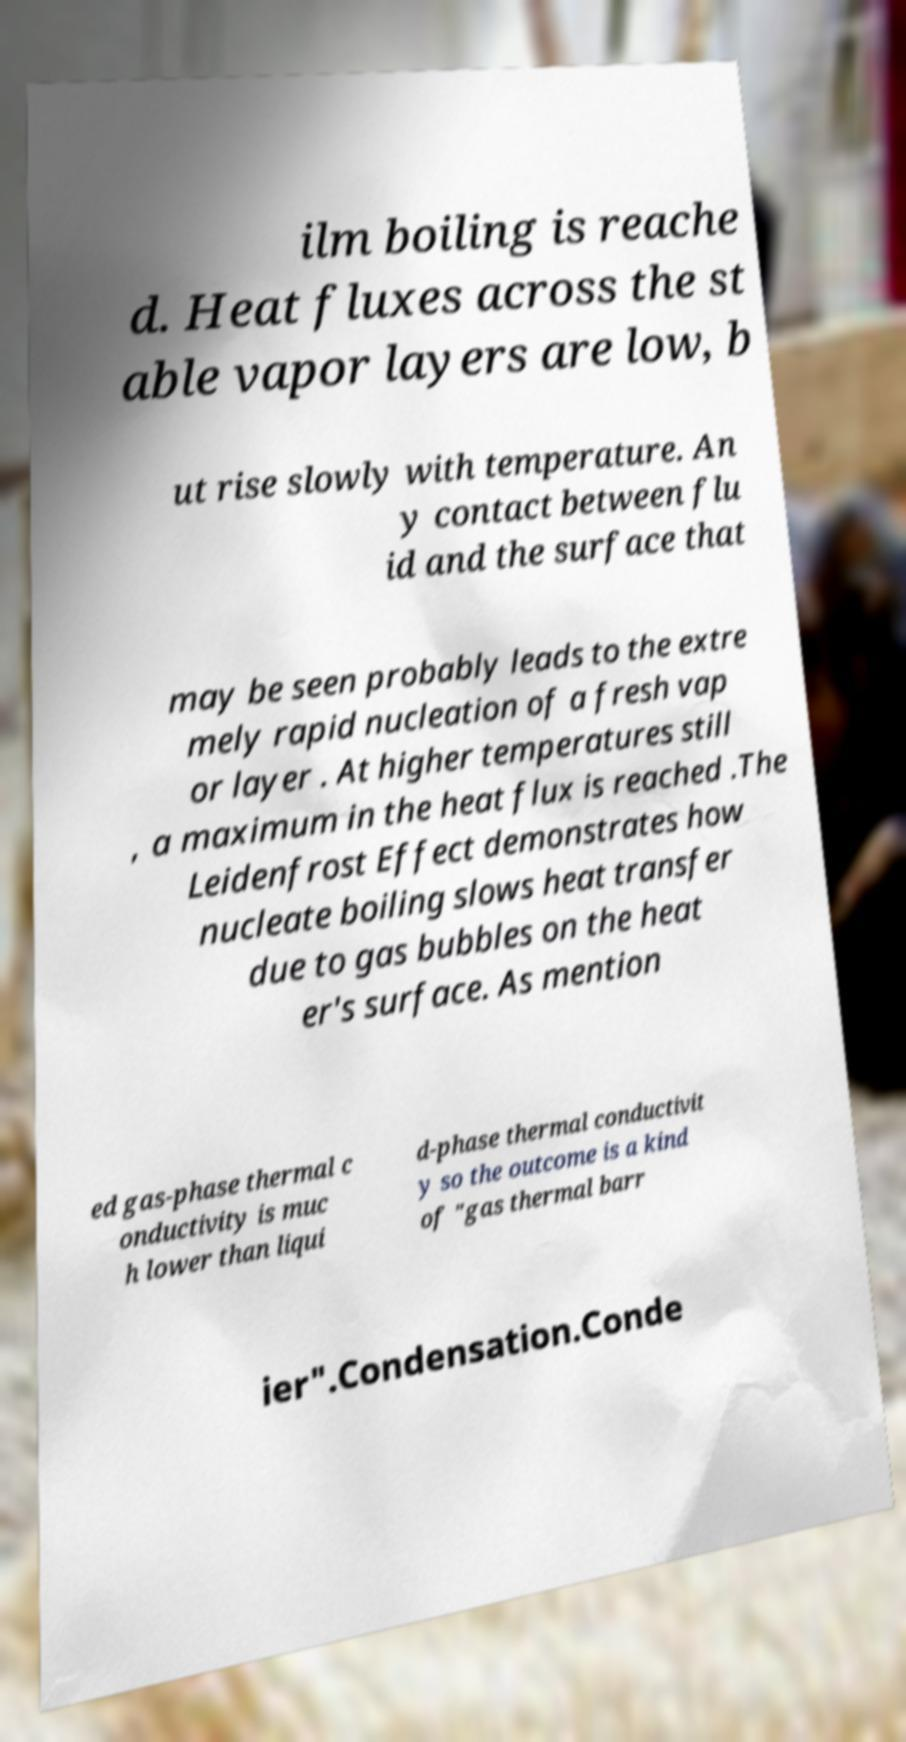For documentation purposes, I need the text within this image transcribed. Could you provide that? ilm boiling is reache d. Heat fluxes across the st able vapor layers are low, b ut rise slowly with temperature. An y contact between flu id and the surface that may be seen probably leads to the extre mely rapid nucleation of a fresh vap or layer . At higher temperatures still , a maximum in the heat flux is reached .The Leidenfrost Effect demonstrates how nucleate boiling slows heat transfer due to gas bubbles on the heat er's surface. As mention ed gas-phase thermal c onductivity is muc h lower than liqui d-phase thermal conductivit y so the outcome is a kind of "gas thermal barr ier".Condensation.Conde 